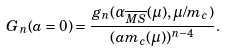<formula> <loc_0><loc_0><loc_500><loc_500>G _ { n } ( a = 0 ) = \frac { g _ { n } ( \alpha _ { \overline { M S } } ( \mu ) , \mu / m _ { c } ) } { ( a m _ { c } ( \mu ) ) ^ { n - 4 } } .</formula> 